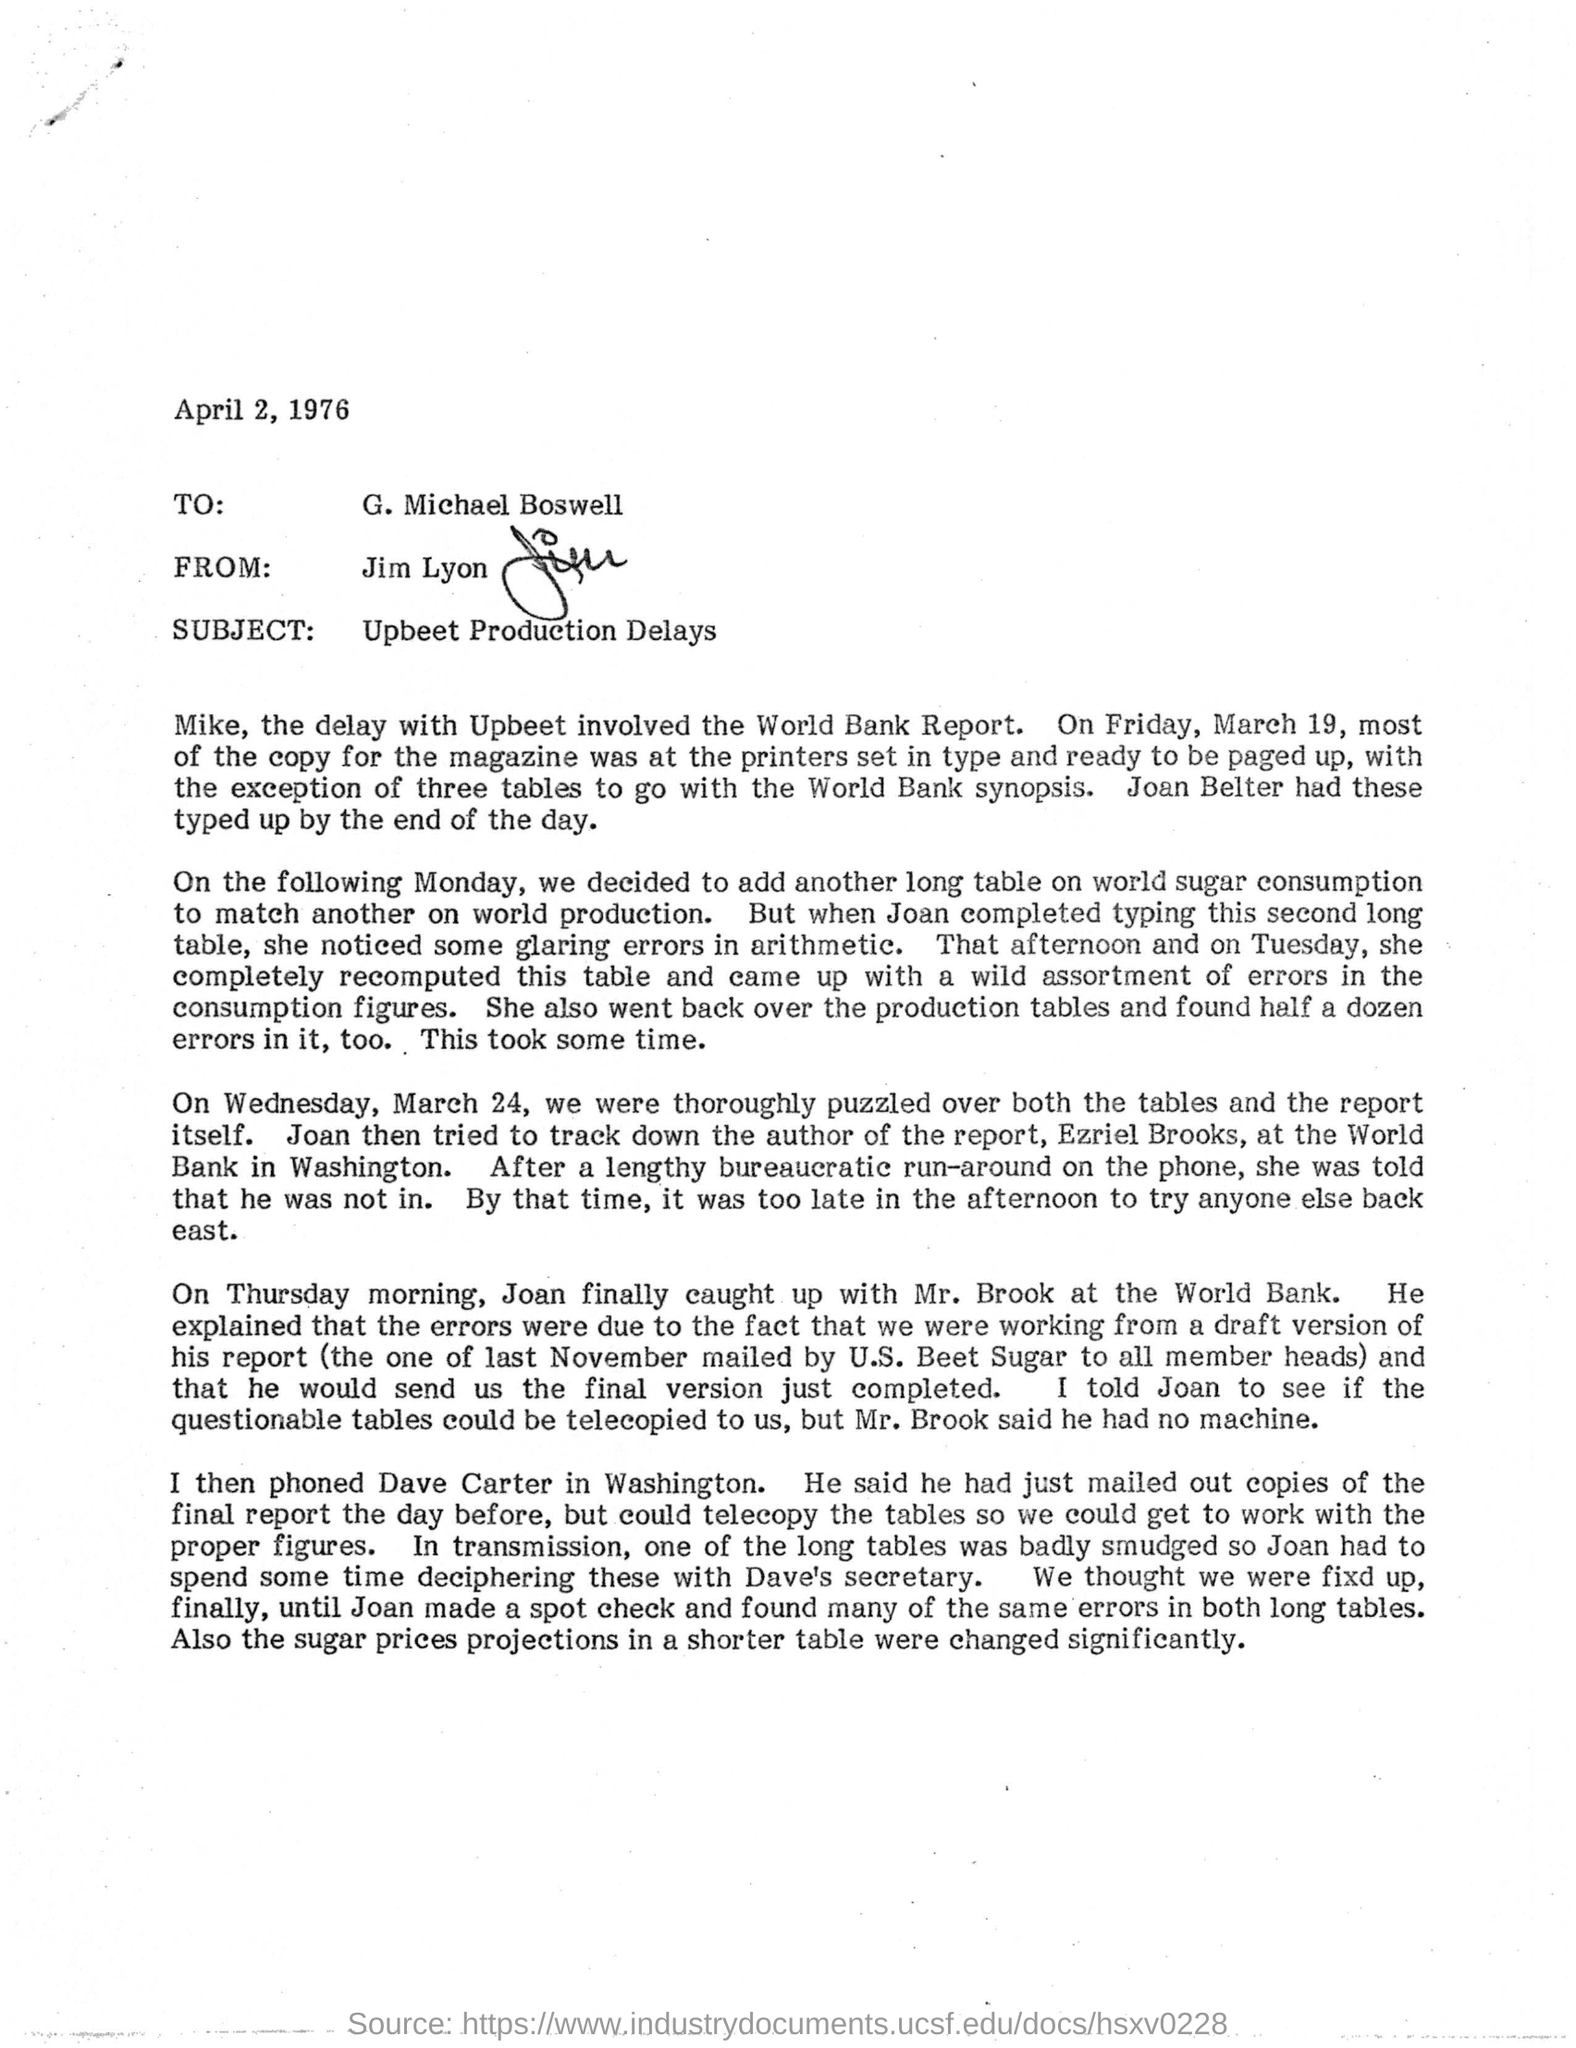What steps were taken to resolve the issues mentioned in the letter? The steps included tracking down the author of the report at the World Bank, telephoning a colleague in Washington for clearer copies of the report, and conducting thorough spot checks on the production and arithmetic tables to correct the errors. Did these steps help in meeting their publication deadlines? The letter does not specify whether the deadlines were met, but it details concerted efforts to correct the errors promptly, suggesting a high priority was placed on resolving the issues to adhere to production schedules as closely as possible. 